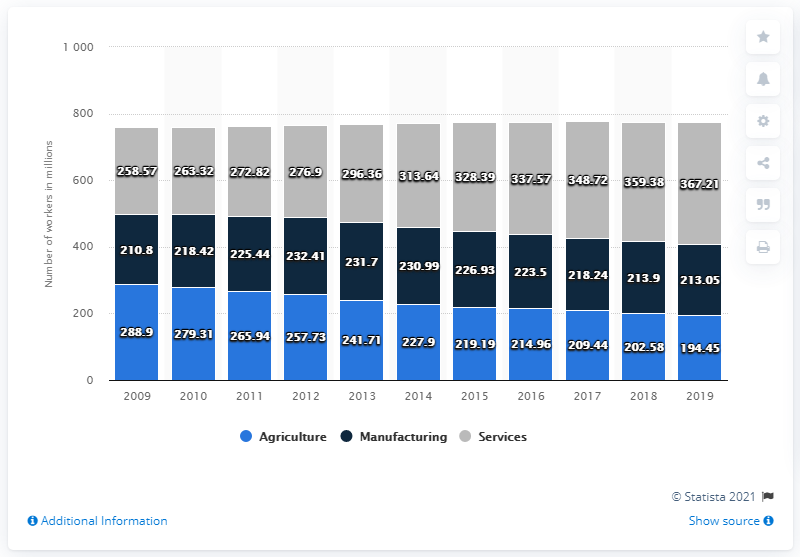Highlight a few significant elements in this photo. In 2019, there were approximately 367.21 million people employed in the service sector in China. In 2019, the breakdown of the total sum in manufacturing and services was 580.26. In 2009, there was a significant increase in the number of workforce breakdowns in the agricultural industry. 